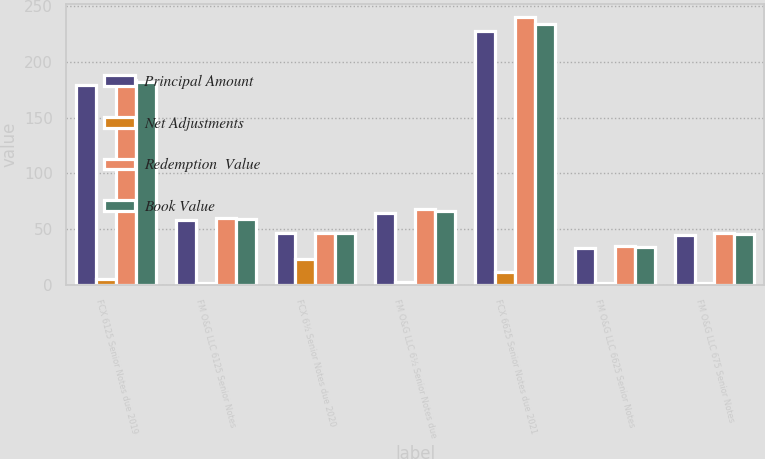Convert chart. <chart><loc_0><loc_0><loc_500><loc_500><stacked_bar_chart><ecel><fcel>FCX 6125 Senior Notes due 2019<fcel>FM O&G LLC 6125 Senior Notes<fcel>FCX 6½ Senior Notes due 2020<fcel>FM O&G LLC 6½ Senior Notes due<fcel>FCX 6625 Senior Notes due 2021<fcel>FM O&G LLC 6625 Senior Notes<fcel>FM O&G LLC 675 Senior Notes<nl><fcel>Principal Amount<fcel>179<fcel>58<fcel>47<fcel>65<fcel>228<fcel>33<fcel>45<nl><fcel>Net Adjustments<fcel>5<fcel>2<fcel>23<fcel>3<fcel>12<fcel>2<fcel>2<nl><fcel>Redemption  Value<fcel>184<fcel>60<fcel>47<fcel>68<fcel>240<fcel>35<fcel>47<nl><fcel>Book Value<fcel>182<fcel>59<fcel>47<fcel>66<fcel>234<fcel>34<fcel>46<nl></chart> 